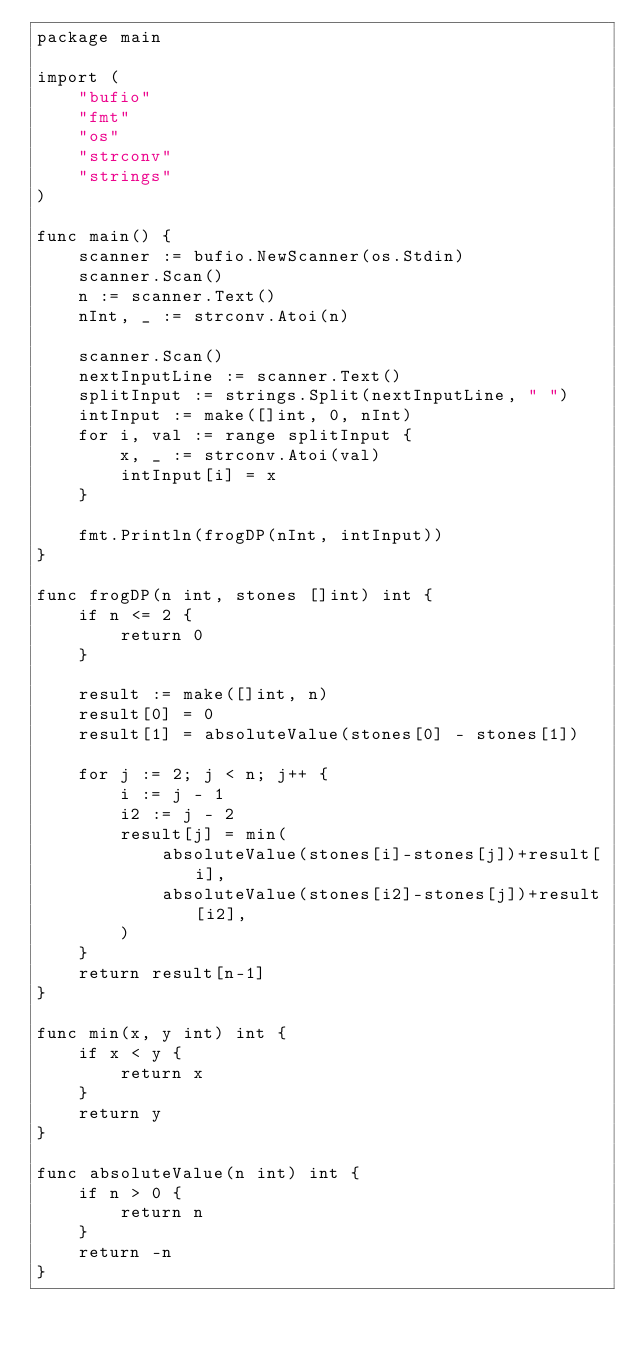Convert code to text. <code><loc_0><loc_0><loc_500><loc_500><_Go_>package main

import (
	"bufio"
	"fmt"
	"os"
	"strconv"
	"strings"
)

func main() {
	scanner := bufio.NewScanner(os.Stdin)
	scanner.Scan()
	n := scanner.Text()
	nInt, _ := strconv.Atoi(n)

	scanner.Scan()
	nextInputLine := scanner.Text()
	splitInput := strings.Split(nextInputLine, " ")
	intInput := make([]int, 0, nInt)
	for i, val := range splitInput {
		x, _ := strconv.Atoi(val)
		intInput[i] = x
	}

	fmt.Println(frogDP(nInt, intInput))
}

func frogDP(n int, stones []int) int {
	if n <= 2 {
		return 0
	}

	result := make([]int, n)
	result[0] = 0
	result[1] = absoluteValue(stones[0] - stones[1])

	for j := 2; j < n; j++ {
		i := j - 1
		i2 := j - 2
		result[j] = min(
			absoluteValue(stones[i]-stones[j])+result[i],
			absoluteValue(stones[i2]-stones[j])+result[i2],
		)
	}
	return result[n-1]
}

func min(x, y int) int {
	if x < y {
		return x
	}
	return y
}

func absoluteValue(n int) int {
	if n > 0 {
		return n
	}
	return -n
}</code> 